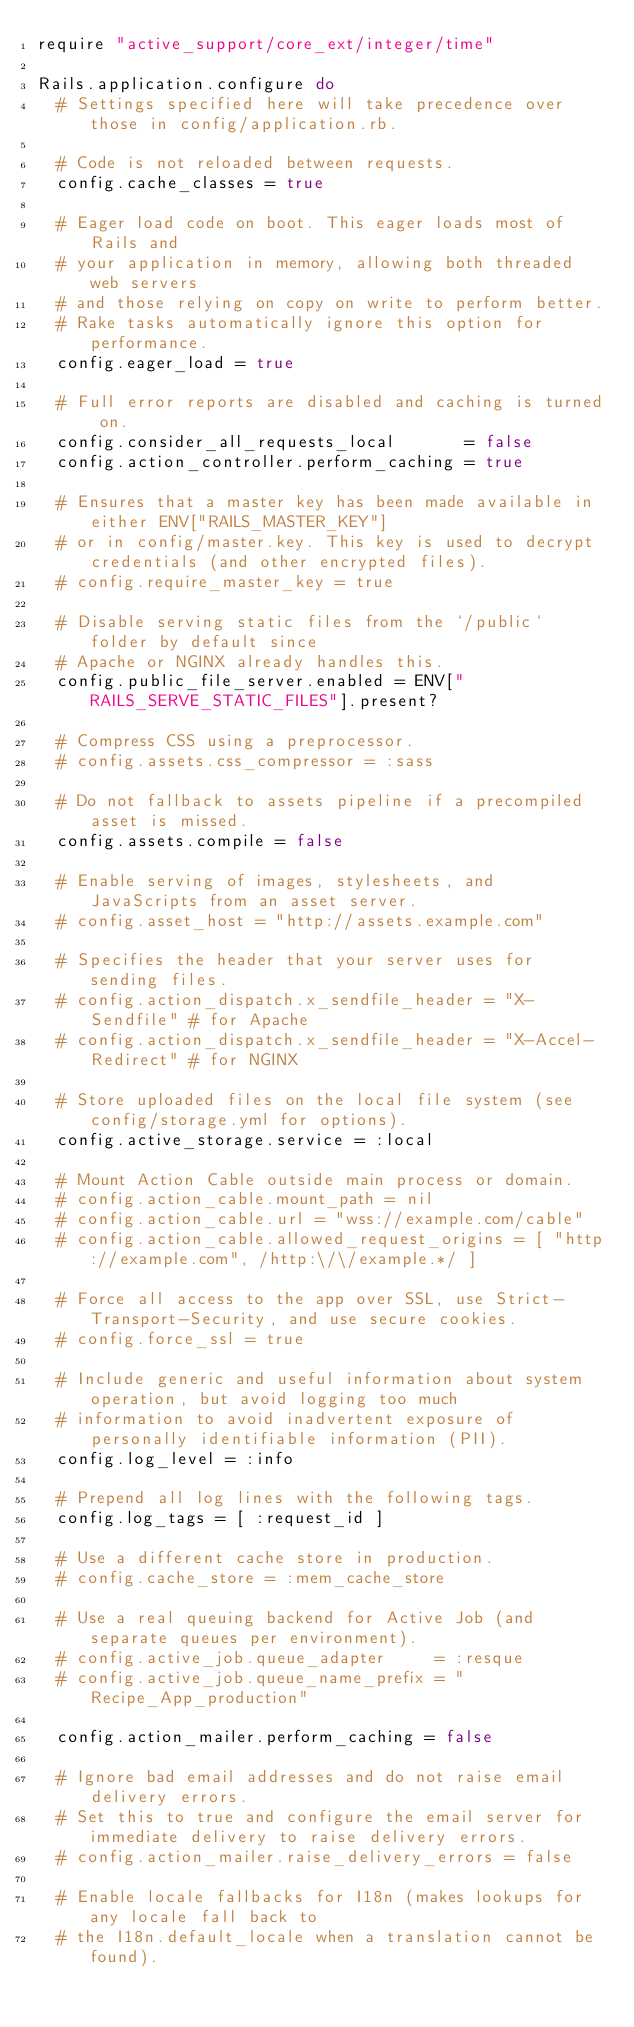<code> <loc_0><loc_0><loc_500><loc_500><_Ruby_>require "active_support/core_ext/integer/time"

Rails.application.configure do
  # Settings specified here will take precedence over those in config/application.rb.

  # Code is not reloaded between requests.
  config.cache_classes = true

  # Eager load code on boot. This eager loads most of Rails and
  # your application in memory, allowing both threaded web servers
  # and those relying on copy on write to perform better.
  # Rake tasks automatically ignore this option for performance.
  config.eager_load = true

  # Full error reports are disabled and caching is turned on.
  config.consider_all_requests_local       = false
  config.action_controller.perform_caching = true

  # Ensures that a master key has been made available in either ENV["RAILS_MASTER_KEY"]
  # or in config/master.key. This key is used to decrypt credentials (and other encrypted files).
  # config.require_master_key = true

  # Disable serving static files from the `/public` folder by default since
  # Apache or NGINX already handles this.
  config.public_file_server.enabled = ENV["RAILS_SERVE_STATIC_FILES"].present?

  # Compress CSS using a preprocessor.
  # config.assets.css_compressor = :sass

  # Do not fallback to assets pipeline if a precompiled asset is missed.
  config.assets.compile = false

  # Enable serving of images, stylesheets, and JavaScripts from an asset server.
  # config.asset_host = "http://assets.example.com"

  # Specifies the header that your server uses for sending files.
  # config.action_dispatch.x_sendfile_header = "X-Sendfile" # for Apache
  # config.action_dispatch.x_sendfile_header = "X-Accel-Redirect" # for NGINX

  # Store uploaded files on the local file system (see config/storage.yml for options).
  config.active_storage.service = :local

  # Mount Action Cable outside main process or domain.
  # config.action_cable.mount_path = nil
  # config.action_cable.url = "wss://example.com/cable"
  # config.action_cable.allowed_request_origins = [ "http://example.com", /http:\/\/example.*/ ]

  # Force all access to the app over SSL, use Strict-Transport-Security, and use secure cookies.
  # config.force_ssl = true

  # Include generic and useful information about system operation, but avoid logging too much
  # information to avoid inadvertent exposure of personally identifiable information (PII).
  config.log_level = :info

  # Prepend all log lines with the following tags.
  config.log_tags = [ :request_id ]

  # Use a different cache store in production.
  # config.cache_store = :mem_cache_store

  # Use a real queuing backend for Active Job (and separate queues per environment).
  # config.active_job.queue_adapter     = :resque
  # config.active_job.queue_name_prefix = "Recipe_App_production"

  config.action_mailer.perform_caching = false

  # Ignore bad email addresses and do not raise email delivery errors.
  # Set this to true and configure the email server for immediate delivery to raise delivery errors.
  # config.action_mailer.raise_delivery_errors = false

  # Enable locale fallbacks for I18n (makes lookups for any locale fall back to
  # the I18n.default_locale when a translation cannot be found).</code> 